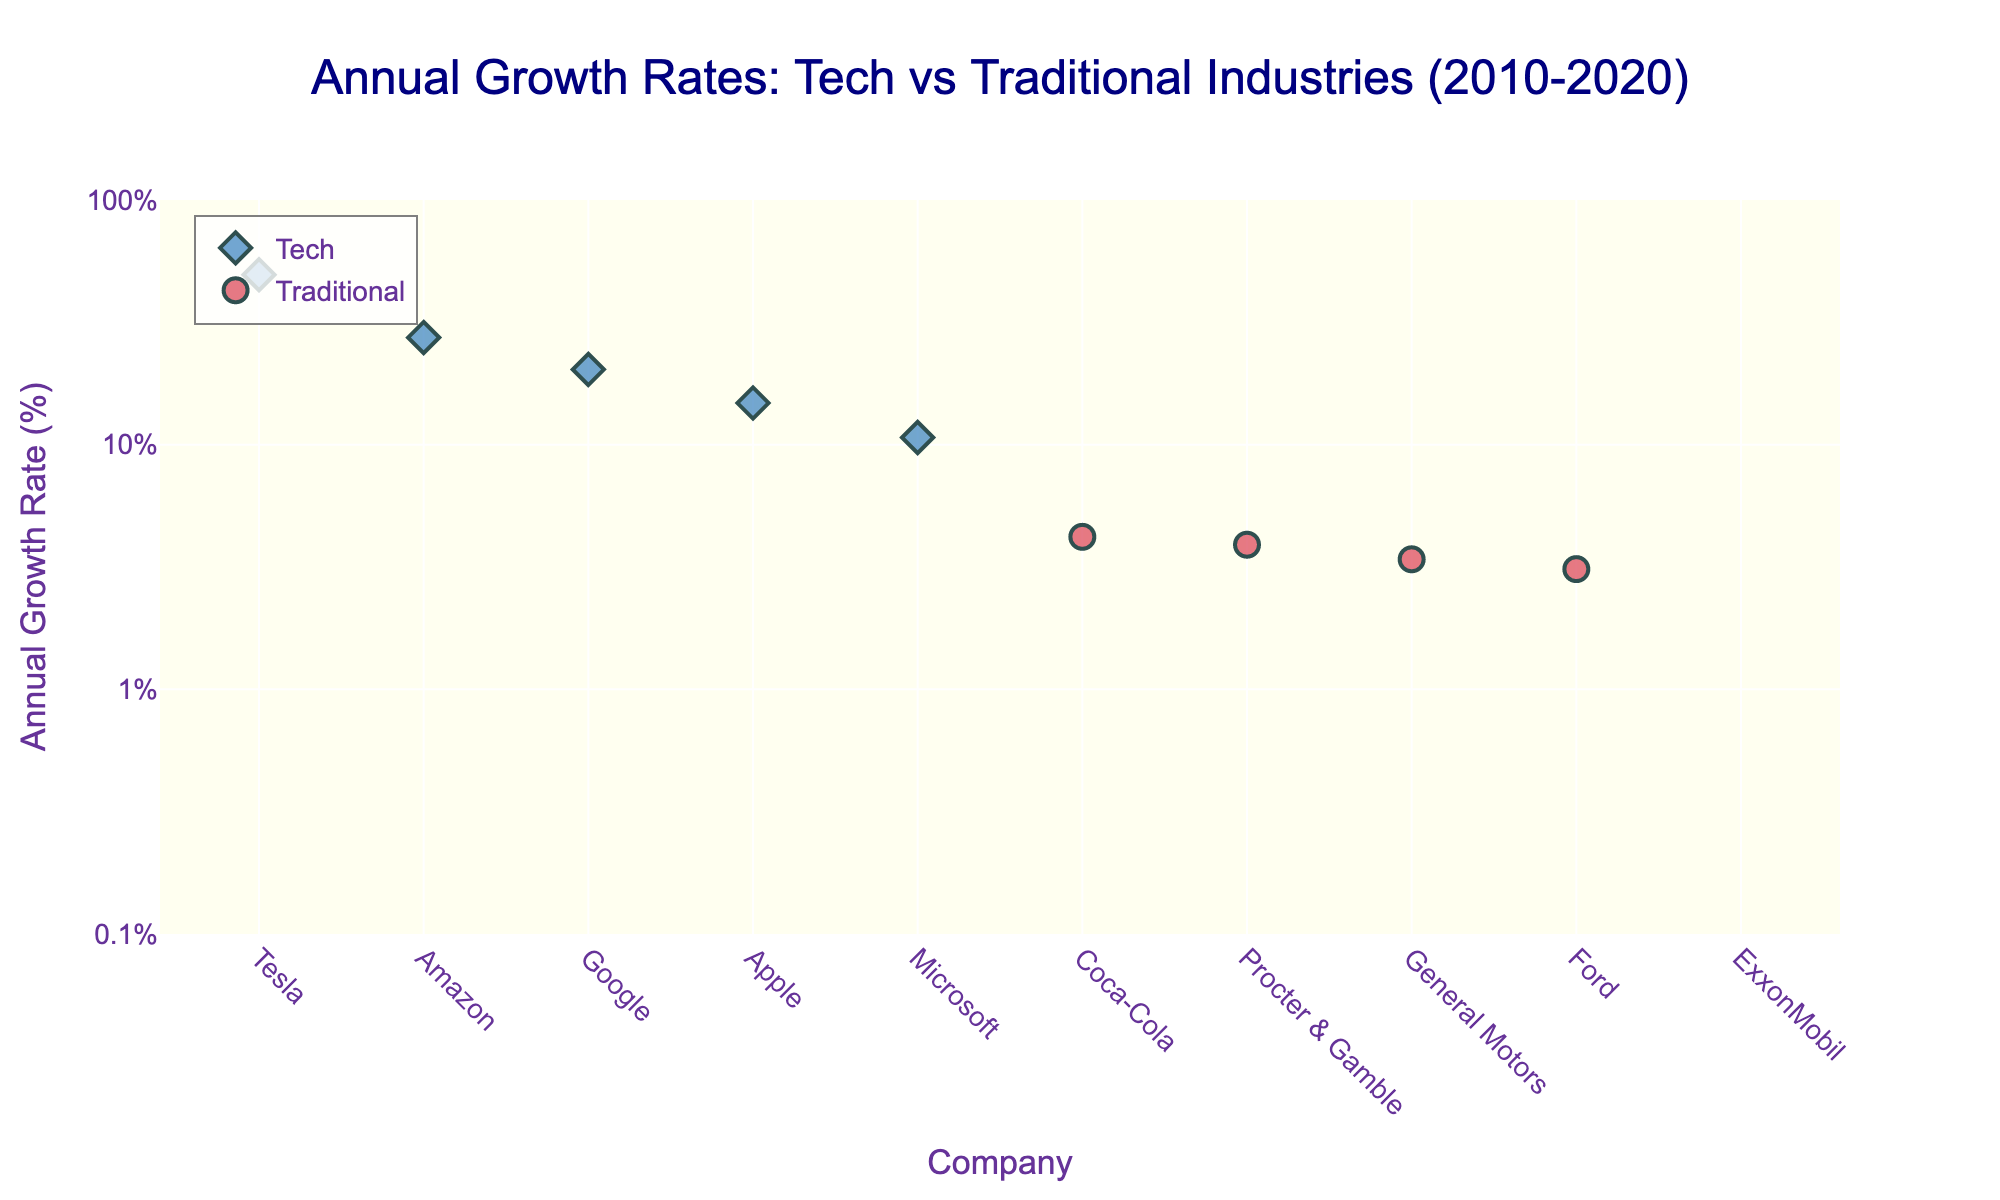What's the title of the figure? The title of the figure can be found at the top and usually summarizes the main subject or finding of the figure. In this case, it's stated clearly in a larger font size.
Answer: Annual Growth Rates: Tech vs Traditional Industries (2010-2020) Which company has the highest annual growth rate? The company with the highest annual growth rate can be identified by finding the highest marker on the y-axis. In this case, Tesla is at the top.
Answer: Tesla How do the symbols differ between tech and traditional industries? The scatter plot uses different markers to distinguish between industries: tech companies are represented by diamonds, while traditional companies are shown as circles.
Answer: Diamonds for tech, circles for traditional What are the tick values on the y-axis? The y-axis has a log scale, and the tick values are shown on the axis to guide the viewer in interpreting the logarithmic increments. They are systematically labeled for clarity.
Answer: 0.1%, 1%, 10%, 100% Which industry has the most companies represented in the figure? By counting the markers for each industry (diamond for tech and circle for traditional), we can determine which industry has more companies represented.
Answer: Technology What's the color used for representing tech companies? The color used for the markers representing tech companies is distinct and visually identifiable from those representing traditional companies.
Answer: Blue (rgba(55, 128, 191, 0.7)) Calculate the average annual growth rate of traditional companies. To find the average growth rate of traditional companies, sum their rates and divide by the number of companies: (3.1 + 3.4 + 4.2 + 3.9 - 1.4)/5 = 13.2/5 = 2.64%
Answer: 2.64% How many companies have a negative growth rate? By inspecting the scatter plot, identify any markers below the 0% growth threshold on the y-axis. There's only one company in this category.
Answer: 1 Compare the highest growth rate in tech versus traditional industries. Identify the highest growth rate for both industries by looking at the highest points within each industry: Tesla for tech with 49.5% and Coca-Cola for traditional with 4.2%.
Answer: 49.5% vs 4.2% What's the median annual growth rate of tech companies? To find the median, list the growth rates of tech companies in ascending order and find the middle value. The sorted values are: 10.7, 14.8, 20.3, 27.4, 49.5, so the median is the middle value, 20.3%.
Answer: 20.3% 